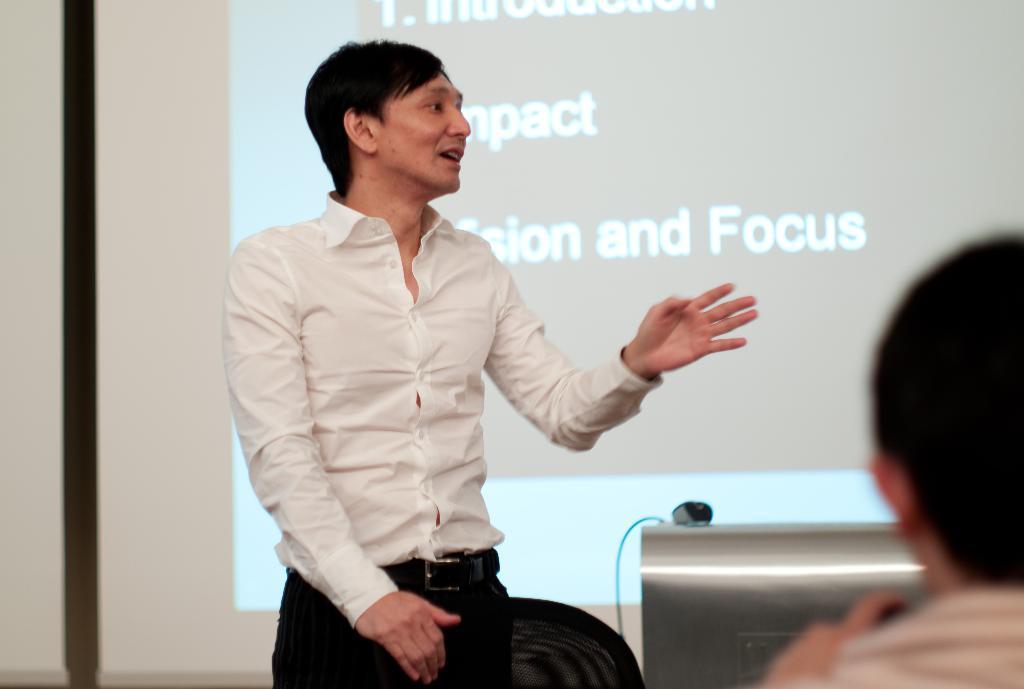How would you summarize this image in a sentence or two? In this image, we can see a man standing and he is wearing a white color shirt, at the right side there is a person sitting, in the background there is a powerpoint presentation. 